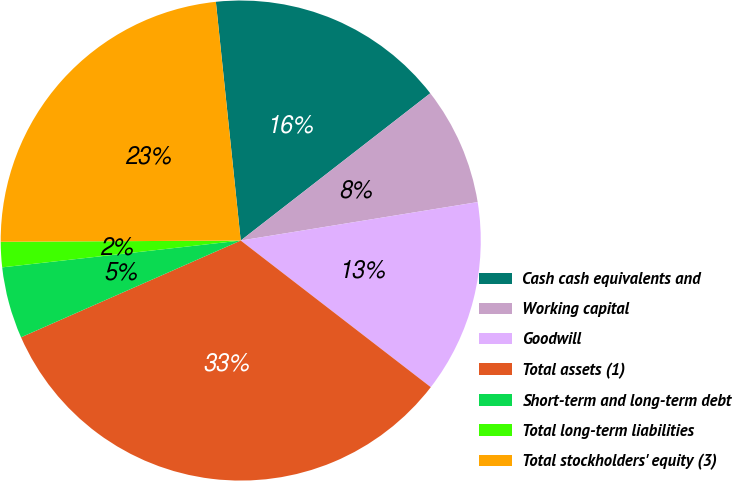Convert chart. <chart><loc_0><loc_0><loc_500><loc_500><pie_chart><fcel>Cash cash equivalents and<fcel>Working capital<fcel>Goodwill<fcel>Total assets (1)<fcel>Short-term and long-term debt<fcel>Total long-term liabilities<fcel>Total stockholders' equity (3)<nl><fcel>16.14%<fcel>7.95%<fcel>13.02%<fcel>32.94%<fcel>4.82%<fcel>1.7%<fcel>23.43%<nl></chart> 